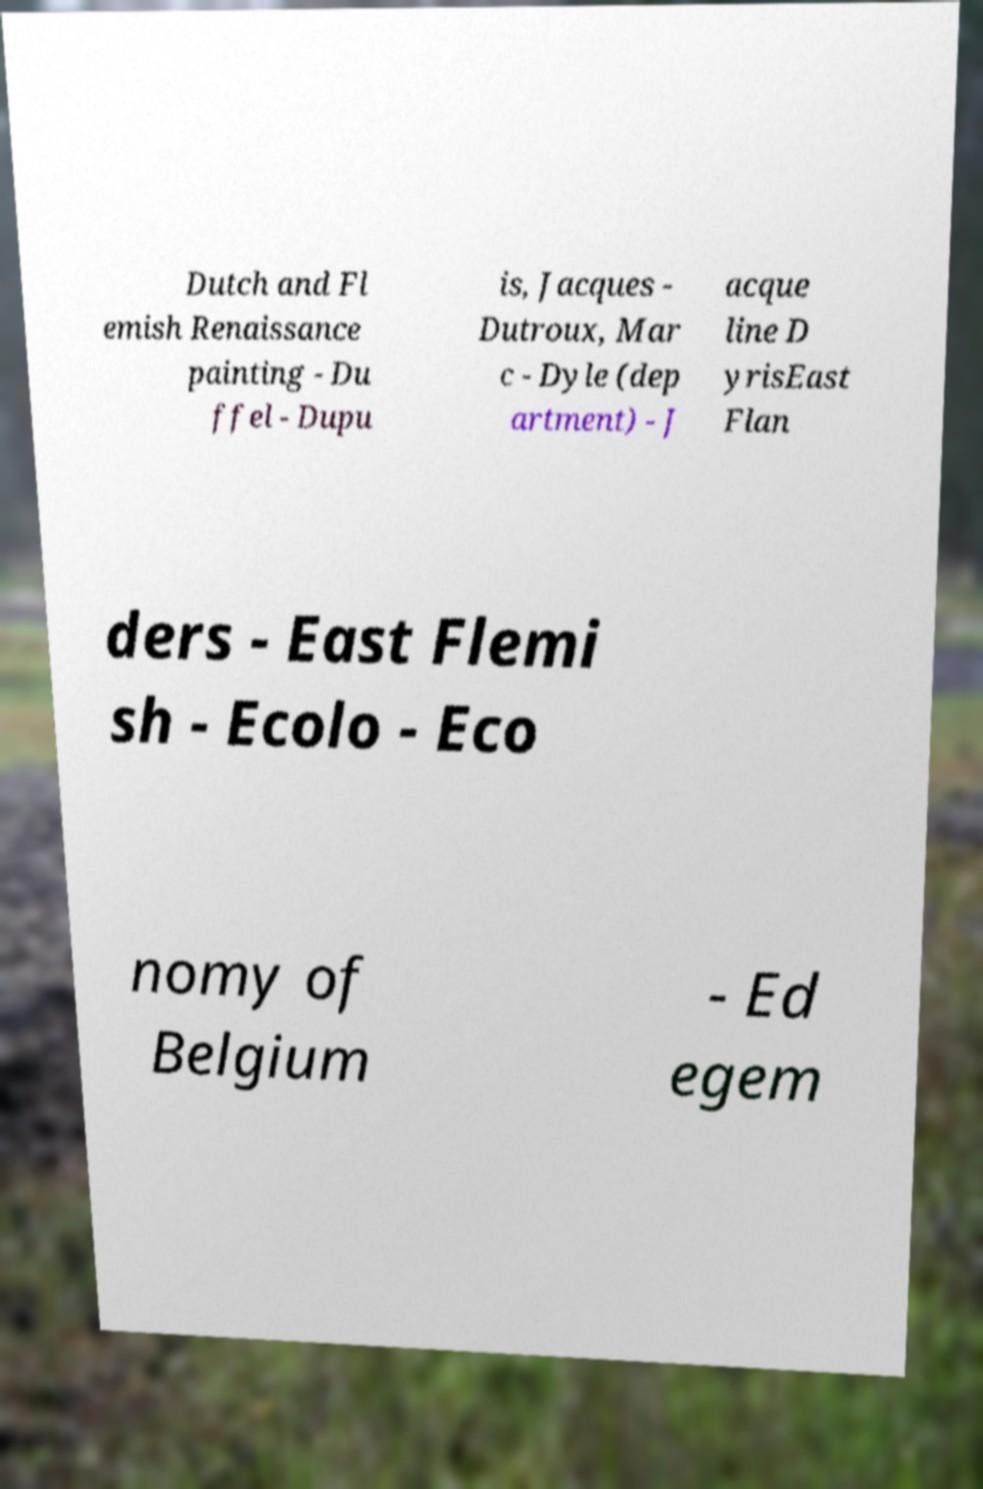I need the written content from this picture converted into text. Can you do that? Dutch and Fl emish Renaissance painting - Du ffel - Dupu is, Jacques - Dutroux, Mar c - Dyle (dep artment) - J acque line D yrisEast Flan ders - East Flemi sh - Ecolo - Eco nomy of Belgium - Ed egem 